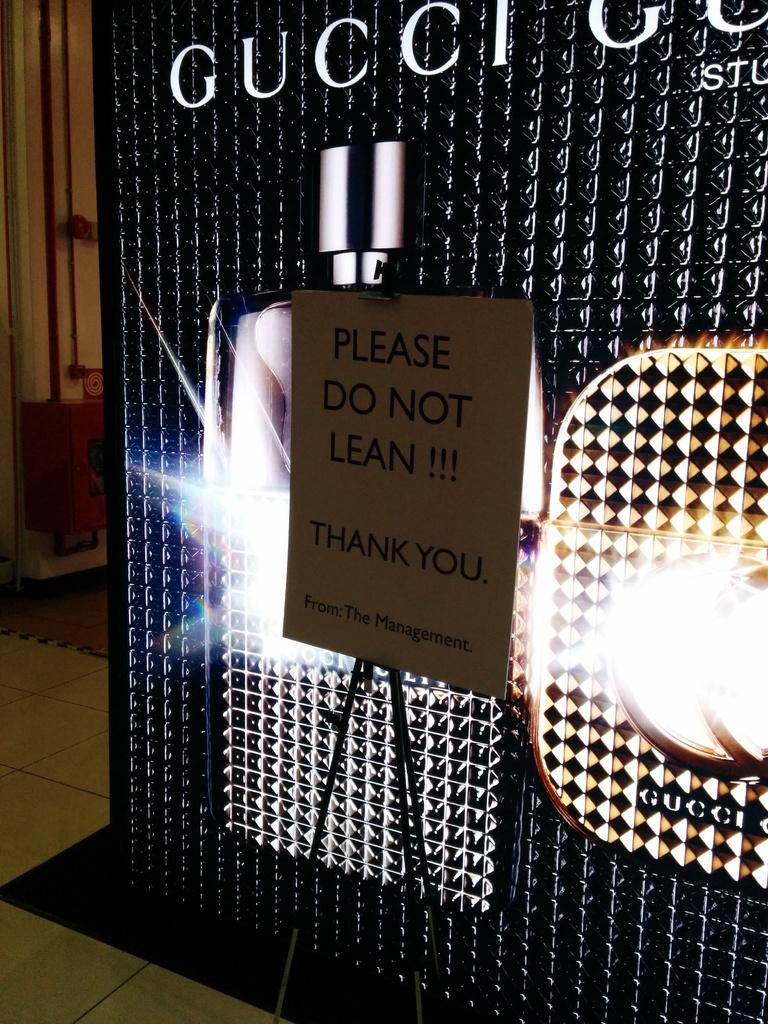What is the main object in the image? There is an advertisement board in the image. What can be seen beneath the advertisement board? The floor is visible in the image. What safety equipment is present in the image? There is a fire cabinet in the image. What type of infrastructure is visible in the image? Pipelines are present in the image. What type of chair is placed on top of the advertisement board in the image? There is no chair present on top of the advertisement board in the image. Can you describe the throne that is visible in the image? There is no throne present in the image. 